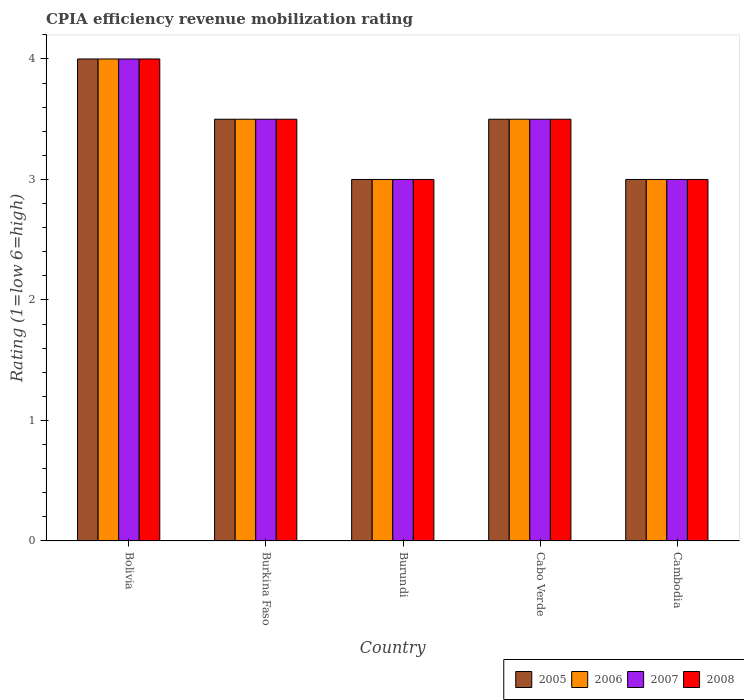Are the number of bars per tick equal to the number of legend labels?
Ensure brevity in your answer.  Yes. Are the number of bars on each tick of the X-axis equal?
Make the answer very short. Yes. How many bars are there on the 1st tick from the left?
Keep it short and to the point. 4. What is the label of the 5th group of bars from the left?
Keep it short and to the point. Cambodia. What is the CPIA rating in 2007 in Burundi?
Provide a succinct answer. 3. In which country was the CPIA rating in 2007 maximum?
Provide a succinct answer. Bolivia. In which country was the CPIA rating in 2005 minimum?
Keep it short and to the point. Burundi. What is the total CPIA rating in 2005 in the graph?
Your answer should be compact. 17. In how many countries, is the CPIA rating in 2006 greater than 3.4?
Your answer should be compact. 3. What is the ratio of the CPIA rating in 2008 in Burundi to that in Cambodia?
Your response must be concise. 1. Is the difference between the CPIA rating in 2008 in Burundi and Cambodia greater than the difference between the CPIA rating in 2006 in Burundi and Cambodia?
Provide a succinct answer. No. What is the difference between the highest and the second highest CPIA rating in 2008?
Provide a short and direct response. -0.5. What is the difference between the highest and the lowest CPIA rating in 2005?
Keep it short and to the point. 1. How many bars are there?
Offer a terse response. 20. What is the difference between two consecutive major ticks on the Y-axis?
Offer a terse response. 1. Are the values on the major ticks of Y-axis written in scientific E-notation?
Keep it short and to the point. No. Does the graph contain any zero values?
Keep it short and to the point. No. Does the graph contain grids?
Provide a succinct answer. No. How many legend labels are there?
Give a very brief answer. 4. How are the legend labels stacked?
Your answer should be compact. Horizontal. What is the title of the graph?
Provide a succinct answer. CPIA efficiency revenue mobilization rating. What is the label or title of the Y-axis?
Offer a terse response. Rating (1=low 6=high). What is the Rating (1=low 6=high) in 2005 in Bolivia?
Ensure brevity in your answer.  4. What is the Rating (1=low 6=high) of 2006 in Bolivia?
Your answer should be very brief. 4. What is the Rating (1=low 6=high) of 2007 in Bolivia?
Ensure brevity in your answer.  4. What is the Rating (1=low 6=high) in 2008 in Bolivia?
Keep it short and to the point. 4. What is the Rating (1=low 6=high) of 2006 in Burkina Faso?
Your answer should be compact. 3.5. What is the Rating (1=low 6=high) of 2008 in Burkina Faso?
Your answer should be very brief. 3.5. What is the Rating (1=low 6=high) in 2005 in Burundi?
Your answer should be compact. 3. What is the Rating (1=low 6=high) in 2005 in Cabo Verde?
Provide a succinct answer. 3.5. What is the Rating (1=low 6=high) in 2007 in Cabo Verde?
Give a very brief answer. 3.5. What is the Rating (1=low 6=high) of 2005 in Cambodia?
Offer a very short reply. 3. What is the Rating (1=low 6=high) in 2006 in Cambodia?
Your answer should be compact. 3. What is the Rating (1=low 6=high) in 2007 in Cambodia?
Offer a very short reply. 3. Across all countries, what is the maximum Rating (1=low 6=high) of 2006?
Give a very brief answer. 4. Across all countries, what is the maximum Rating (1=low 6=high) in 2007?
Provide a short and direct response. 4. Across all countries, what is the minimum Rating (1=low 6=high) in 2005?
Give a very brief answer. 3. Across all countries, what is the minimum Rating (1=low 6=high) of 2007?
Provide a short and direct response. 3. What is the total Rating (1=low 6=high) in 2007 in the graph?
Offer a terse response. 17. What is the total Rating (1=low 6=high) of 2008 in the graph?
Provide a short and direct response. 17. What is the difference between the Rating (1=low 6=high) in 2006 in Bolivia and that in Burkina Faso?
Offer a very short reply. 0.5. What is the difference between the Rating (1=low 6=high) of 2008 in Bolivia and that in Burkina Faso?
Keep it short and to the point. 0.5. What is the difference between the Rating (1=low 6=high) of 2006 in Bolivia and that in Burundi?
Offer a terse response. 1. What is the difference between the Rating (1=low 6=high) of 2007 in Bolivia and that in Burundi?
Your response must be concise. 1. What is the difference between the Rating (1=low 6=high) of 2008 in Bolivia and that in Burundi?
Ensure brevity in your answer.  1. What is the difference between the Rating (1=low 6=high) of 2006 in Bolivia and that in Cabo Verde?
Make the answer very short. 0.5. What is the difference between the Rating (1=low 6=high) of 2008 in Bolivia and that in Cabo Verde?
Ensure brevity in your answer.  0.5. What is the difference between the Rating (1=low 6=high) of 2008 in Bolivia and that in Cambodia?
Provide a short and direct response. 1. What is the difference between the Rating (1=low 6=high) in 2005 in Burkina Faso and that in Burundi?
Make the answer very short. 0.5. What is the difference between the Rating (1=low 6=high) in 2007 in Burkina Faso and that in Burundi?
Your answer should be very brief. 0.5. What is the difference between the Rating (1=low 6=high) of 2005 in Burkina Faso and that in Cabo Verde?
Ensure brevity in your answer.  0. What is the difference between the Rating (1=low 6=high) of 2008 in Burkina Faso and that in Cabo Verde?
Offer a very short reply. 0. What is the difference between the Rating (1=low 6=high) of 2007 in Burkina Faso and that in Cambodia?
Provide a succinct answer. 0.5. What is the difference between the Rating (1=low 6=high) of 2007 in Burundi and that in Cabo Verde?
Your response must be concise. -0.5. What is the difference between the Rating (1=low 6=high) in 2008 in Burundi and that in Cabo Verde?
Ensure brevity in your answer.  -0.5. What is the difference between the Rating (1=low 6=high) of 2006 in Burundi and that in Cambodia?
Your answer should be compact. 0. What is the difference between the Rating (1=low 6=high) of 2007 in Burundi and that in Cambodia?
Give a very brief answer. 0. What is the difference between the Rating (1=low 6=high) in 2008 in Burundi and that in Cambodia?
Offer a very short reply. 0. What is the difference between the Rating (1=low 6=high) in 2008 in Cabo Verde and that in Cambodia?
Your answer should be very brief. 0.5. What is the difference between the Rating (1=low 6=high) of 2005 in Bolivia and the Rating (1=low 6=high) of 2008 in Burkina Faso?
Offer a terse response. 0.5. What is the difference between the Rating (1=low 6=high) of 2006 in Bolivia and the Rating (1=low 6=high) of 2007 in Burkina Faso?
Keep it short and to the point. 0.5. What is the difference between the Rating (1=low 6=high) of 2005 in Bolivia and the Rating (1=low 6=high) of 2006 in Burundi?
Your answer should be very brief. 1. What is the difference between the Rating (1=low 6=high) in 2006 in Bolivia and the Rating (1=low 6=high) in 2007 in Burundi?
Your response must be concise. 1. What is the difference between the Rating (1=low 6=high) in 2007 in Bolivia and the Rating (1=low 6=high) in 2008 in Burundi?
Your response must be concise. 1. What is the difference between the Rating (1=low 6=high) of 2005 in Bolivia and the Rating (1=low 6=high) of 2007 in Cabo Verde?
Keep it short and to the point. 0.5. What is the difference between the Rating (1=low 6=high) of 2006 in Bolivia and the Rating (1=low 6=high) of 2007 in Cabo Verde?
Ensure brevity in your answer.  0.5. What is the difference between the Rating (1=low 6=high) in 2006 in Bolivia and the Rating (1=low 6=high) in 2008 in Cabo Verde?
Make the answer very short. 0.5. What is the difference between the Rating (1=low 6=high) of 2007 in Bolivia and the Rating (1=low 6=high) of 2008 in Cabo Verde?
Offer a very short reply. 0.5. What is the difference between the Rating (1=low 6=high) of 2006 in Bolivia and the Rating (1=low 6=high) of 2007 in Cambodia?
Provide a succinct answer. 1. What is the difference between the Rating (1=low 6=high) in 2005 in Burkina Faso and the Rating (1=low 6=high) in 2006 in Burundi?
Your answer should be compact. 0.5. What is the difference between the Rating (1=low 6=high) in 2005 in Burkina Faso and the Rating (1=low 6=high) in 2008 in Burundi?
Offer a terse response. 0.5. What is the difference between the Rating (1=low 6=high) in 2005 in Burkina Faso and the Rating (1=low 6=high) in 2006 in Cabo Verde?
Your response must be concise. 0. What is the difference between the Rating (1=low 6=high) in 2006 in Burkina Faso and the Rating (1=low 6=high) in 2007 in Cabo Verde?
Keep it short and to the point. 0. What is the difference between the Rating (1=low 6=high) in 2006 in Burkina Faso and the Rating (1=low 6=high) in 2008 in Cabo Verde?
Provide a succinct answer. 0. What is the difference between the Rating (1=low 6=high) in 2005 in Burkina Faso and the Rating (1=low 6=high) in 2006 in Cambodia?
Your answer should be very brief. 0.5. What is the difference between the Rating (1=low 6=high) in 2005 in Burkina Faso and the Rating (1=low 6=high) in 2008 in Cambodia?
Your response must be concise. 0.5. What is the difference between the Rating (1=low 6=high) in 2006 in Burkina Faso and the Rating (1=low 6=high) in 2007 in Cambodia?
Give a very brief answer. 0.5. What is the difference between the Rating (1=low 6=high) in 2006 in Burkina Faso and the Rating (1=low 6=high) in 2008 in Cambodia?
Your answer should be compact. 0.5. What is the difference between the Rating (1=low 6=high) of 2005 in Burundi and the Rating (1=low 6=high) of 2006 in Cabo Verde?
Your answer should be compact. -0.5. What is the difference between the Rating (1=low 6=high) in 2005 in Burundi and the Rating (1=low 6=high) in 2008 in Cabo Verde?
Give a very brief answer. -0.5. What is the difference between the Rating (1=low 6=high) in 2006 in Burundi and the Rating (1=low 6=high) in 2008 in Cabo Verde?
Your answer should be compact. -0.5. What is the difference between the Rating (1=low 6=high) in 2005 in Burundi and the Rating (1=low 6=high) in 2007 in Cambodia?
Offer a very short reply. 0. What is the difference between the Rating (1=low 6=high) in 2005 in Burundi and the Rating (1=low 6=high) in 2008 in Cambodia?
Keep it short and to the point. 0. What is the difference between the Rating (1=low 6=high) in 2007 in Burundi and the Rating (1=low 6=high) in 2008 in Cambodia?
Provide a succinct answer. 0. What is the difference between the Rating (1=low 6=high) in 2005 in Cabo Verde and the Rating (1=low 6=high) in 2006 in Cambodia?
Make the answer very short. 0.5. What is the difference between the Rating (1=low 6=high) of 2005 in Cabo Verde and the Rating (1=low 6=high) of 2007 in Cambodia?
Ensure brevity in your answer.  0.5. What is the difference between the Rating (1=low 6=high) in 2005 in Cabo Verde and the Rating (1=low 6=high) in 2008 in Cambodia?
Offer a terse response. 0.5. What is the difference between the Rating (1=low 6=high) in 2006 in Cabo Verde and the Rating (1=low 6=high) in 2007 in Cambodia?
Keep it short and to the point. 0.5. What is the difference between the Rating (1=low 6=high) of 2006 in Cabo Verde and the Rating (1=low 6=high) of 2008 in Cambodia?
Ensure brevity in your answer.  0.5. What is the difference between the Rating (1=low 6=high) in 2007 in Cabo Verde and the Rating (1=low 6=high) in 2008 in Cambodia?
Offer a very short reply. 0.5. What is the average Rating (1=low 6=high) in 2006 per country?
Keep it short and to the point. 3.4. What is the average Rating (1=low 6=high) in 2007 per country?
Your answer should be very brief. 3.4. What is the average Rating (1=low 6=high) of 2008 per country?
Your answer should be compact. 3.4. What is the difference between the Rating (1=low 6=high) in 2006 and Rating (1=low 6=high) in 2007 in Bolivia?
Your answer should be compact. 0. What is the difference between the Rating (1=low 6=high) in 2006 and Rating (1=low 6=high) in 2008 in Bolivia?
Give a very brief answer. 0. What is the difference between the Rating (1=low 6=high) in 2007 and Rating (1=low 6=high) in 2008 in Bolivia?
Provide a short and direct response. 0. What is the difference between the Rating (1=low 6=high) in 2005 and Rating (1=low 6=high) in 2006 in Burkina Faso?
Offer a very short reply. 0. What is the difference between the Rating (1=low 6=high) in 2006 and Rating (1=low 6=high) in 2008 in Burkina Faso?
Your answer should be very brief. 0. What is the difference between the Rating (1=low 6=high) in 2007 and Rating (1=low 6=high) in 2008 in Burkina Faso?
Make the answer very short. 0. What is the difference between the Rating (1=low 6=high) in 2005 and Rating (1=low 6=high) in 2007 in Burundi?
Ensure brevity in your answer.  0. What is the difference between the Rating (1=low 6=high) in 2006 and Rating (1=low 6=high) in 2008 in Burundi?
Give a very brief answer. 0. What is the difference between the Rating (1=low 6=high) in 2005 and Rating (1=low 6=high) in 2006 in Cabo Verde?
Make the answer very short. 0. What is the difference between the Rating (1=low 6=high) in 2005 and Rating (1=low 6=high) in 2007 in Cabo Verde?
Keep it short and to the point. 0. What is the difference between the Rating (1=low 6=high) in 2006 and Rating (1=low 6=high) in 2007 in Cabo Verde?
Provide a short and direct response. 0. What is the difference between the Rating (1=low 6=high) in 2007 and Rating (1=low 6=high) in 2008 in Cabo Verde?
Provide a short and direct response. 0. What is the difference between the Rating (1=low 6=high) of 2005 and Rating (1=low 6=high) of 2006 in Cambodia?
Your answer should be very brief. 0. What is the difference between the Rating (1=low 6=high) of 2005 and Rating (1=low 6=high) of 2007 in Cambodia?
Your answer should be very brief. 0. What is the difference between the Rating (1=low 6=high) of 2005 and Rating (1=low 6=high) of 2008 in Cambodia?
Ensure brevity in your answer.  0. What is the ratio of the Rating (1=low 6=high) in 2006 in Bolivia to that in Burkina Faso?
Keep it short and to the point. 1.14. What is the ratio of the Rating (1=low 6=high) of 2008 in Bolivia to that in Burkina Faso?
Give a very brief answer. 1.14. What is the ratio of the Rating (1=low 6=high) in 2005 in Bolivia to that in Burundi?
Your response must be concise. 1.33. What is the ratio of the Rating (1=low 6=high) of 2006 in Bolivia to that in Burundi?
Your answer should be very brief. 1.33. What is the ratio of the Rating (1=low 6=high) of 2005 in Bolivia to that in Cabo Verde?
Provide a short and direct response. 1.14. What is the ratio of the Rating (1=low 6=high) in 2007 in Bolivia to that in Cabo Verde?
Provide a succinct answer. 1.14. What is the ratio of the Rating (1=low 6=high) in 2005 in Bolivia to that in Cambodia?
Ensure brevity in your answer.  1.33. What is the ratio of the Rating (1=low 6=high) of 2006 in Bolivia to that in Cambodia?
Keep it short and to the point. 1.33. What is the ratio of the Rating (1=low 6=high) of 2005 in Burkina Faso to that in Burundi?
Your response must be concise. 1.17. What is the ratio of the Rating (1=low 6=high) of 2007 in Burkina Faso to that in Burundi?
Give a very brief answer. 1.17. What is the ratio of the Rating (1=low 6=high) in 2008 in Burkina Faso to that in Burundi?
Provide a short and direct response. 1.17. What is the ratio of the Rating (1=low 6=high) in 2005 in Burkina Faso to that in Cabo Verde?
Your answer should be compact. 1. What is the ratio of the Rating (1=low 6=high) of 2006 in Burkina Faso to that in Cabo Verde?
Offer a terse response. 1. What is the ratio of the Rating (1=low 6=high) in 2007 in Burkina Faso to that in Cabo Verde?
Make the answer very short. 1. What is the ratio of the Rating (1=low 6=high) in 2008 in Burkina Faso to that in Cabo Verde?
Offer a terse response. 1. What is the ratio of the Rating (1=low 6=high) in 2005 in Burkina Faso to that in Cambodia?
Ensure brevity in your answer.  1.17. What is the ratio of the Rating (1=low 6=high) in 2007 in Burkina Faso to that in Cambodia?
Provide a short and direct response. 1.17. What is the ratio of the Rating (1=low 6=high) of 2006 in Burundi to that in Cabo Verde?
Provide a succinct answer. 0.86. What is the ratio of the Rating (1=low 6=high) of 2008 in Burundi to that in Cabo Verde?
Your response must be concise. 0.86. What is the ratio of the Rating (1=low 6=high) in 2006 in Burundi to that in Cambodia?
Ensure brevity in your answer.  1. What is the ratio of the Rating (1=low 6=high) of 2005 in Cabo Verde to that in Cambodia?
Offer a terse response. 1.17. What is the ratio of the Rating (1=low 6=high) of 2007 in Cabo Verde to that in Cambodia?
Offer a very short reply. 1.17. What is the difference between the highest and the second highest Rating (1=low 6=high) in 2005?
Provide a succinct answer. 0.5. What is the difference between the highest and the second highest Rating (1=low 6=high) in 2008?
Provide a short and direct response. 0.5. What is the difference between the highest and the lowest Rating (1=low 6=high) in 2008?
Offer a very short reply. 1. 